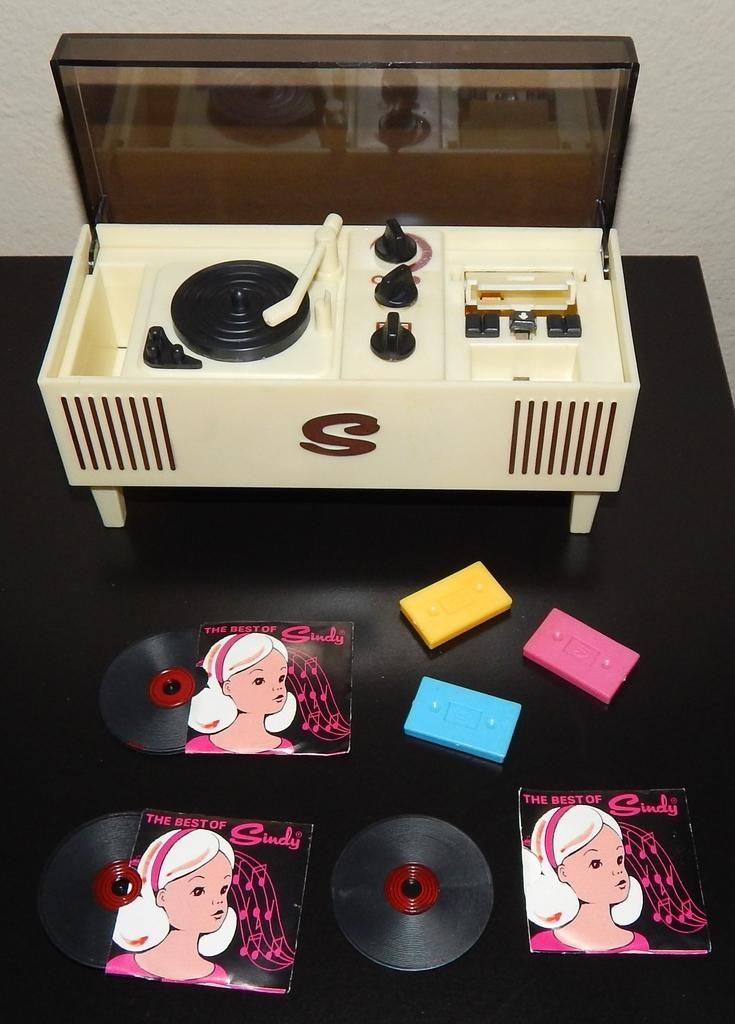<image>
Create a compact narrative representing the image presented. CD covers on a table that says "The Best of Sindy". 